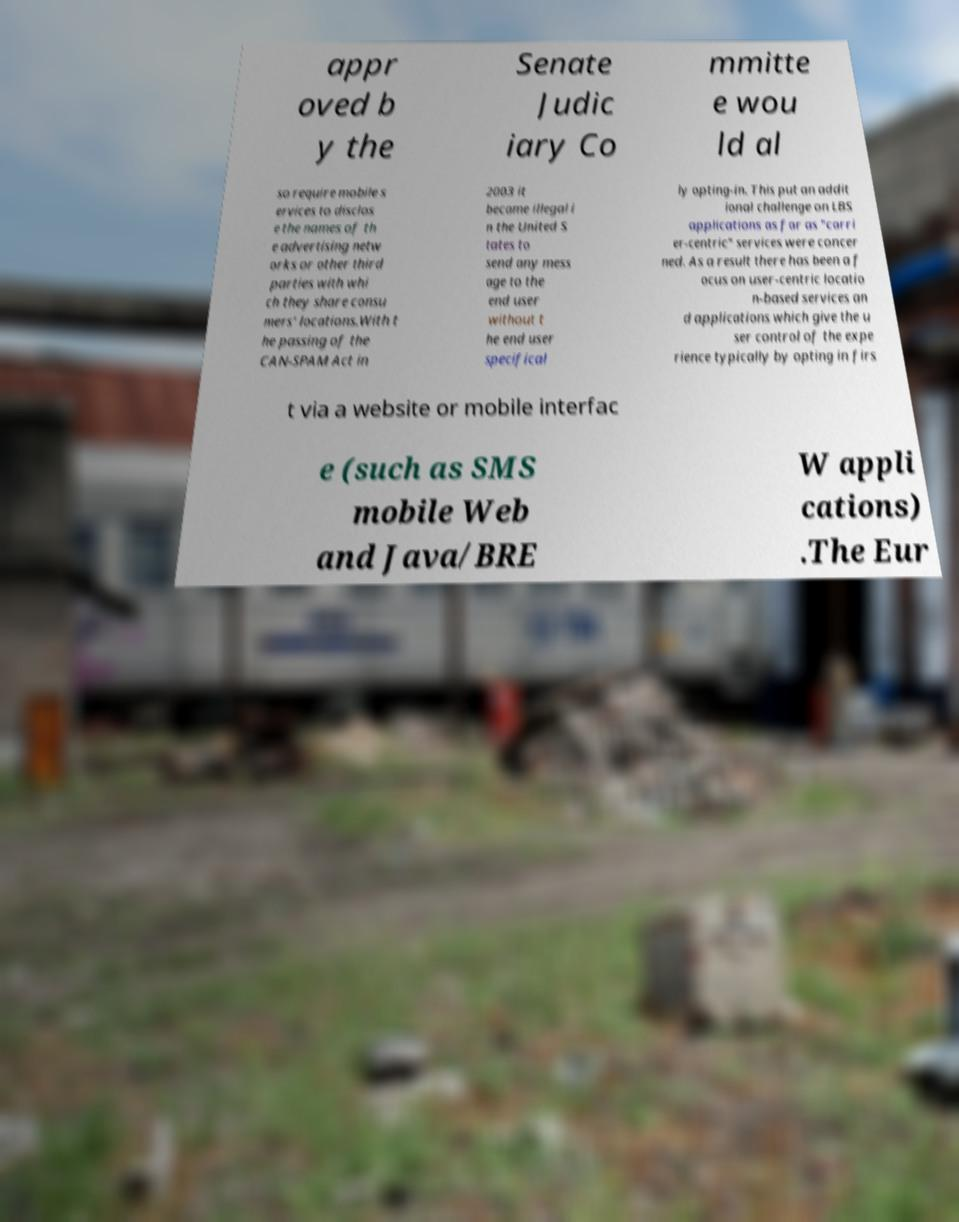There's text embedded in this image that I need extracted. Can you transcribe it verbatim? appr oved b y the Senate Judic iary Co mmitte e wou ld al so require mobile s ervices to disclos e the names of th e advertising netw orks or other third parties with whi ch they share consu mers' locations.With t he passing of the CAN-SPAM Act in 2003 it became illegal i n the United S tates to send any mess age to the end user without t he end user specifical ly opting-in. This put an addit ional challenge on LBS applications as far as "carri er-centric" services were concer ned. As a result there has been a f ocus on user-centric locatio n-based services an d applications which give the u ser control of the expe rience typically by opting in firs t via a website or mobile interfac e (such as SMS mobile Web and Java/BRE W appli cations) .The Eur 